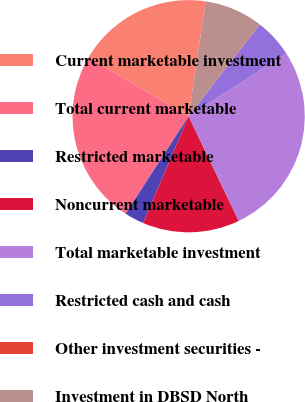Convert chart. <chart><loc_0><loc_0><loc_500><loc_500><pie_chart><fcel>Current marketable investment<fcel>Total current marketable<fcel>Restricted marketable<fcel>Noncurrent marketable<fcel>Total marketable investment<fcel>Restricted cash and cash<fcel>Other investment securities -<fcel>Investment in DBSD North<nl><fcel>18.9%<fcel>24.3%<fcel>2.72%<fcel>13.51%<fcel>26.99%<fcel>5.42%<fcel>0.03%<fcel>8.12%<nl></chart> 